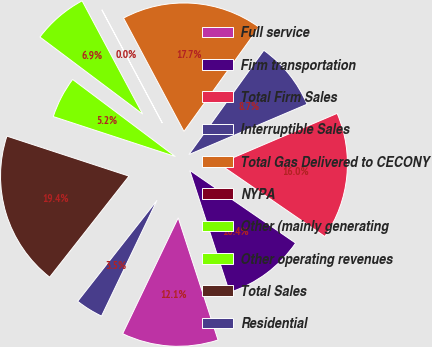Convert chart. <chart><loc_0><loc_0><loc_500><loc_500><pie_chart><fcel>Full service<fcel>Firm transportation<fcel>Total Firm Sales<fcel>Interruptible Sales<fcel>Total Gas Delivered to CECONY<fcel>NYPA<fcel>Other (mainly generating<fcel>Other operating revenues<fcel>Total Sales<fcel>Residential<nl><fcel>12.13%<fcel>10.4%<fcel>15.99%<fcel>8.67%<fcel>17.71%<fcel>0.02%<fcel>6.94%<fcel>5.21%<fcel>19.44%<fcel>3.48%<nl></chart> 